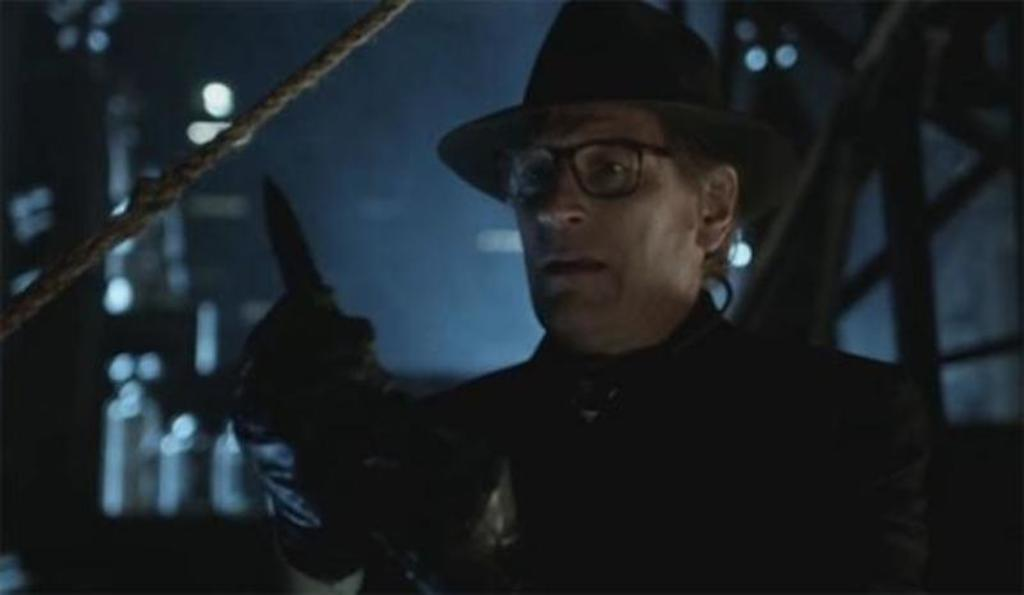What is the overall lighting condition in the image? The image is dark. Can you describe the person in the image? The person in the image is wearing a black dress and a black hat. What object can be seen in the image besides the person? There is a rope in the image. What is the color of the background in the image? The background of the image is dark. How many bears are sitting on the table in the image? There are no bears or tables present in the image. What type of ink is being used by the person in the image? There is no indication of ink or writing in the image. 